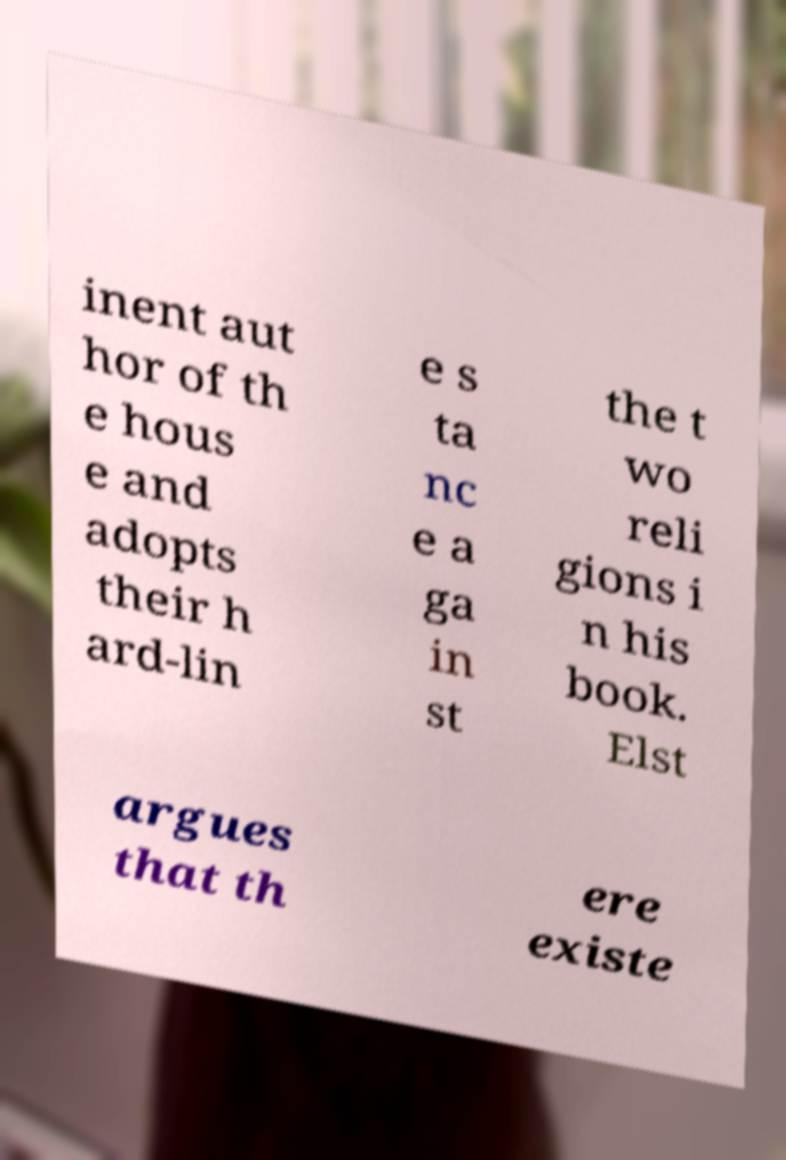There's text embedded in this image that I need extracted. Can you transcribe it verbatim? inent aut hor of th e hous e and adopts their h ard-lin e s ta nc e a ga in st the t wo reli gions i n his book. Elst argues that th ere existe 